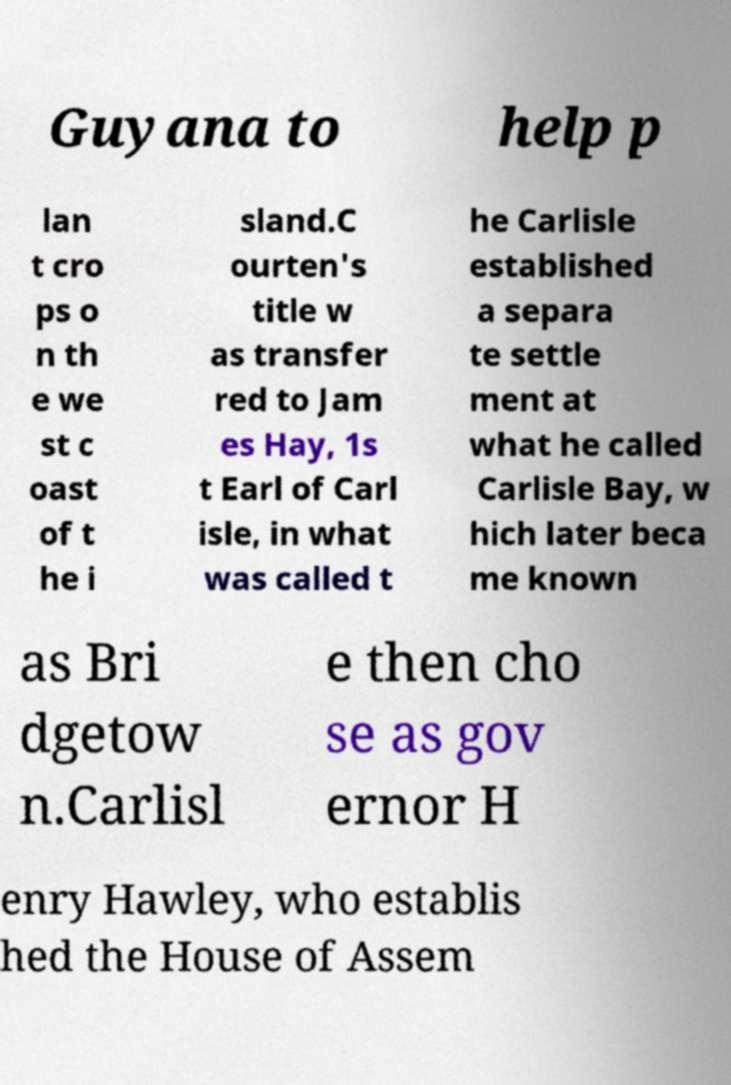Please read and relay the text visible in this image. What does it say? Guyana to help p lan t cro ps o n th e we st c oast of t he i sland.C ourten's title w as transfer red to Jam es Hay, 1s t Earl of Carl isle, in what was called t he Carlisle established a separa te settle ment at what he called Carlisle Bay, w hich later beca me known as Bri dgetow n.Carlisl e then cho se as gov ernor H enry Hawley, who establis hed the House of Assem 